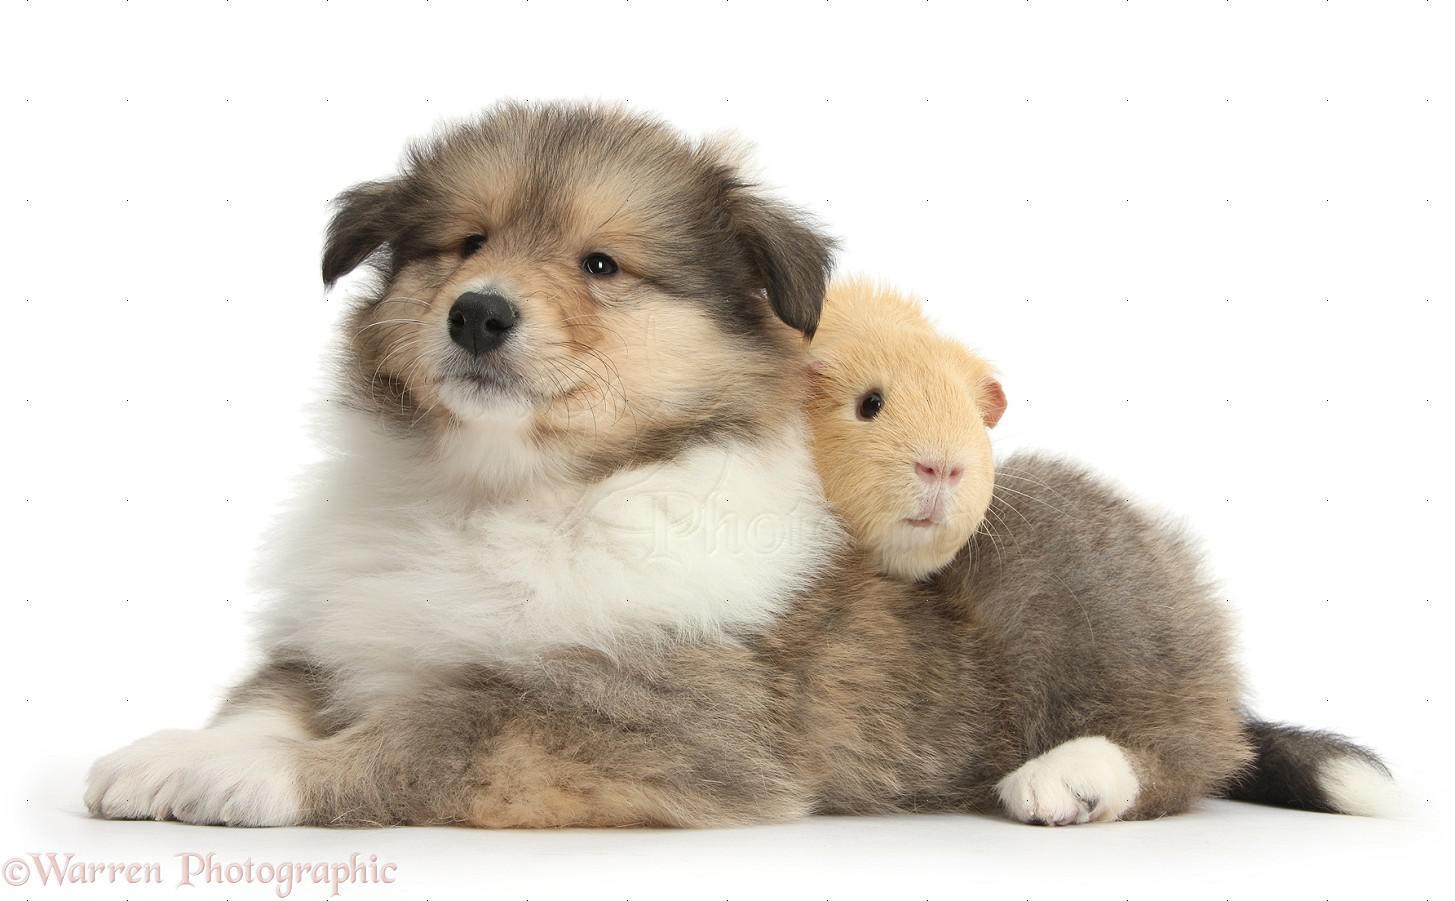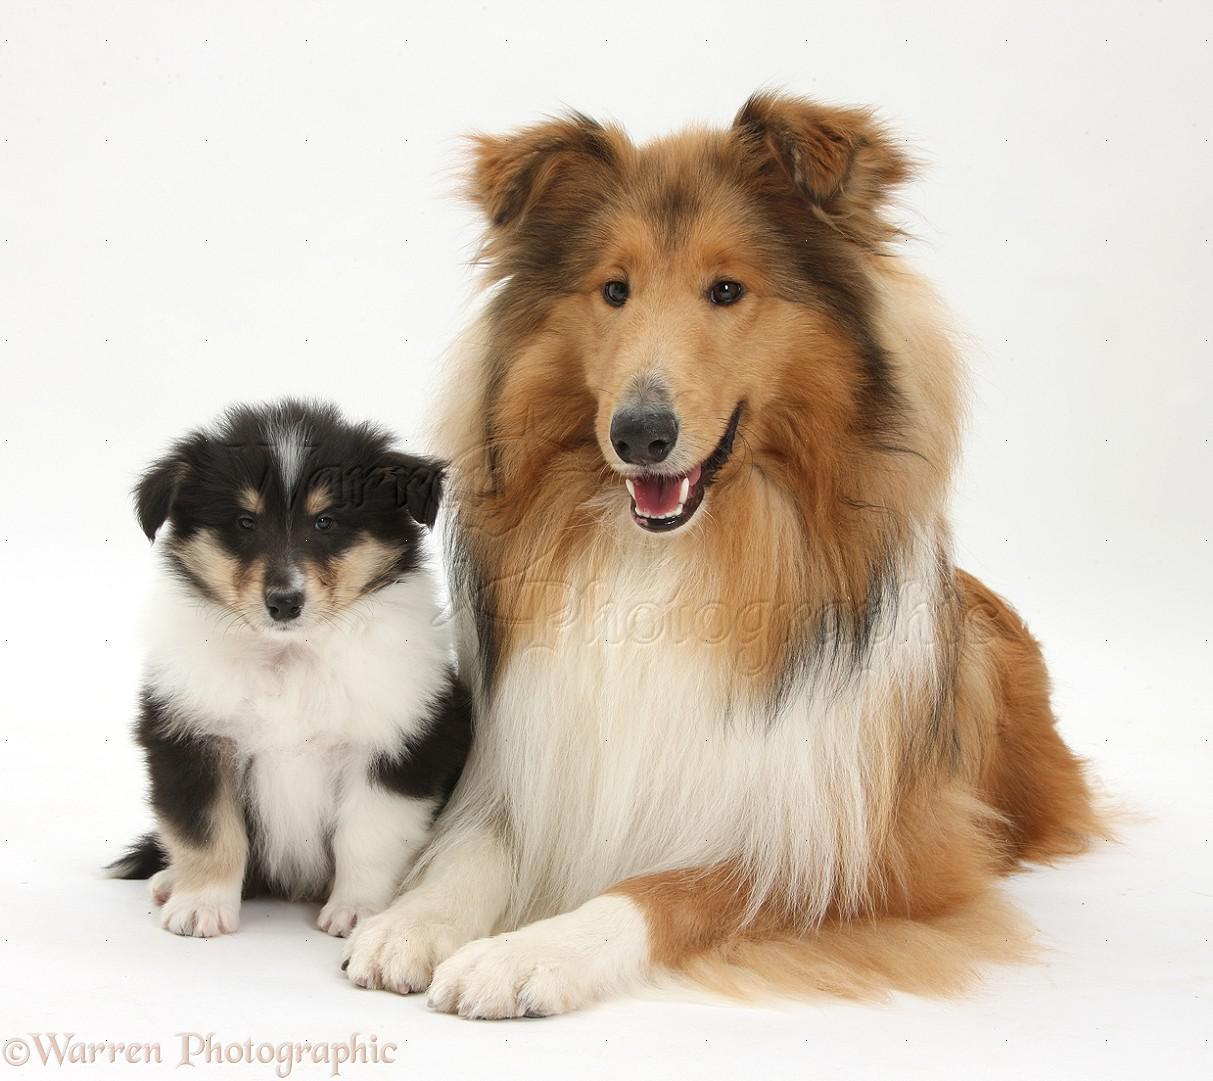The first image is the image on the left, the second image is the image on the right. Considering the images on both sides, is "The right image contains exactly two dogs." valid? Answer yes or no. Yes. The first image is the image on the left, the second image is the image on the right. Analyze the images presented: Is the assertion "A reclining adult collie is posed alongside a collie pup sitting upright." valid? Answer yes or no. Yes. 